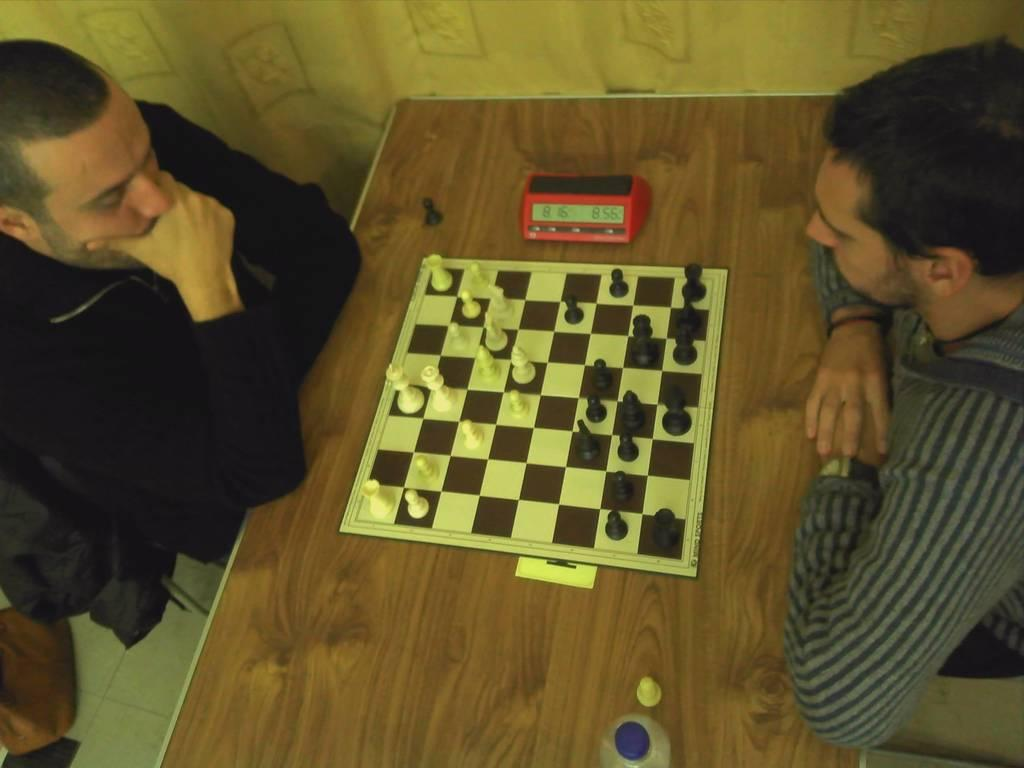How many people are present in the image? There are two people in the image. What are the people doing in the image? The people are sitting on chairs. What is on the table in the image? There is a chess board and a timer on the table. What type of game is being played in the image? The people are playing chess, as evidenced by the chess board and chess coins. What color of paint is being used by the rabbit in the image? There is no rabbit present in the image, and therefore no paint or painting activity can be observed. 